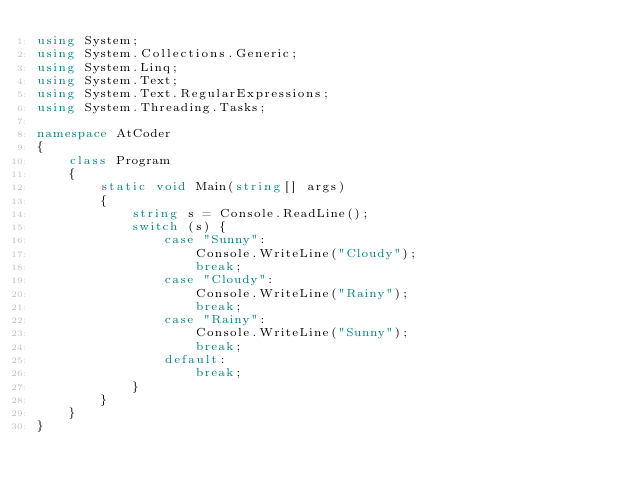Convert code to text. <code><loc_0><loc_0><loc_500><loc_500><_C#_>using System;
using System.Collections.Generic;
using System.Linq;
using System.Text;
using System.Text.RegularExpressions;
using System.Threading.Tasks;

namespace AtCoder
{
    class Program
    {
        static void Main(string[] args)
        {
            string s = Console.ReadLine();
            switch (s) {
                case "Sunny":
                    Console.WriteLine("Cloudy");
                    break;
                case "Cloudy":
                    Console.WriteLine("Rainy");
                    break;
                case "Rainy":
                    Console.WriteLine("Sunny");
                    break;
                default:
                    break;
            }
        }
    }
}
</code> 